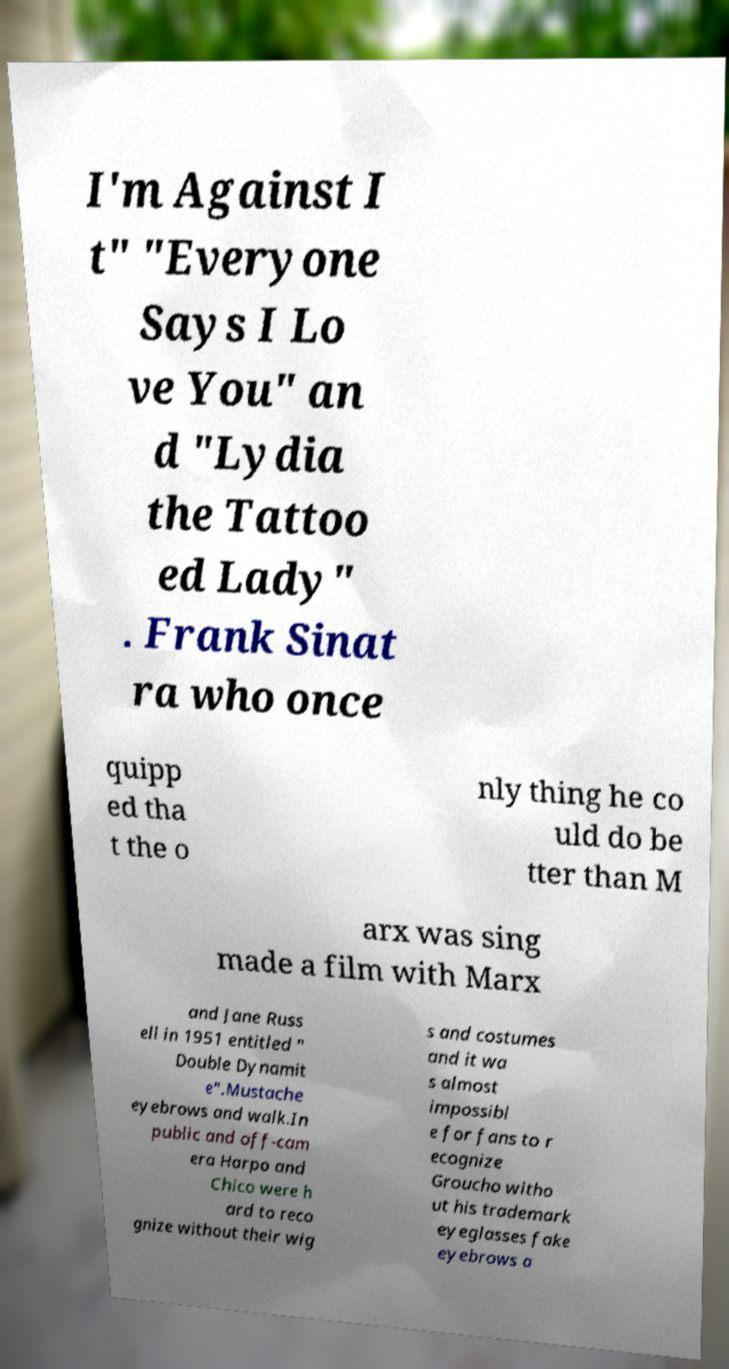For documentation purposes, I need the text within this image transcribed. Could you provide that? I'm Against I t" "Everyone Says I Lo ve You" an d "Lydia the Tattoo ed Lady" . Frank Sinat ra who once quipp ed tha t the o nly thing he co uld do be tter than M arx was sing made a film with Marx and Jane Russ ell in 1951 entitled " Double Dynamit e".Mustache eyebrows and walk.In public and off-cam era Harpo and Chico were h ard to reco gnize without their wig s and costumes and it wa s almost impossibl e for fans to r ecognize Groucho witho ut his trademark eyeglasses fake eyebrows a 